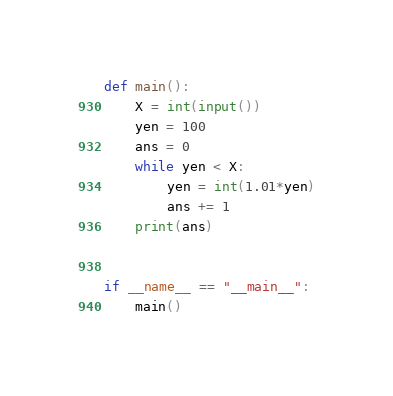<code> <loc_0><loc_0><loc_500><loc_500><_Python_>def main():
    X = int(input())
    yen = 100
    ans = 0
    while yen < X:
        yen = int(1.01*yen)
        ans += 1
    print(ans)


if __name__ == "__main__":
    main()
</code> 